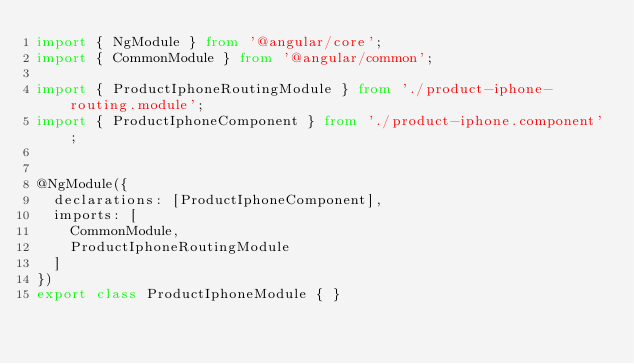Convert code to text. <code><loc_0><loc_0><loc_500><loc_500><_TypeScript_>import { NgModule } from '@angular/core';
import { CommonModule } from '@angular/common';

import { ProductIphoneRoutingModule } from './product-iphone-routing.module';
import { ProductIphoneComponent } from './product-iphone.component';


@NgModule({
  declarations: [ProductIphoneComponent],
  imports: [
    CommonModule,
    ProductIphoneRoutingModule
  ]
})
export class ProductIphoneModule { }
</code> 